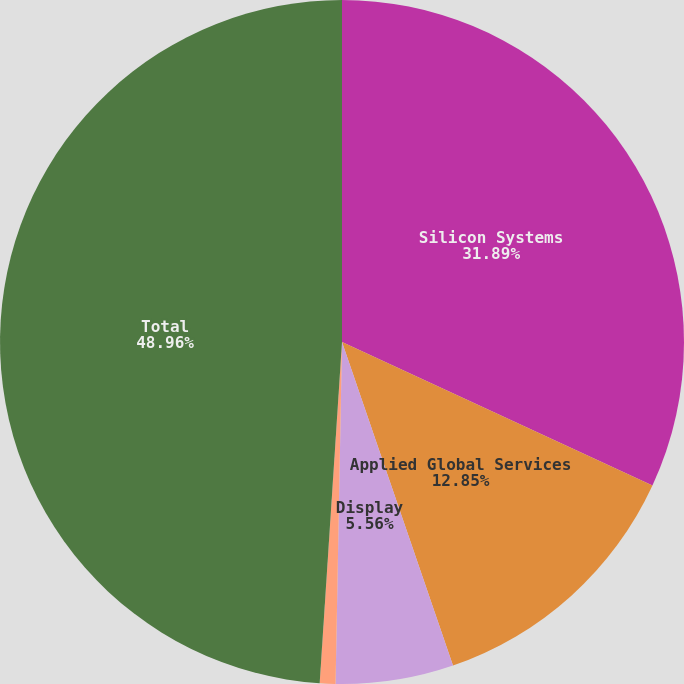<chart> <loc_0><loc_0><loc_500><loc_500><pie_chart><fcel>Silicon Systems<fcel>Applied Global Services<fcel>Display<fcel>Energy and Environmental<fcel>Total<nl><fcel>31.89%<fcel>12.85%<fcel>5.56%<fcel>0.74%<fcel>48.96%<nl></chart> 